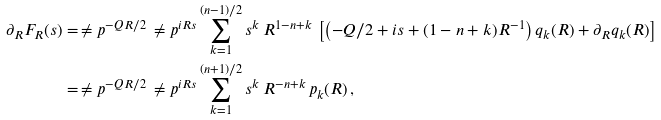<formula> <loc_0><loc_0><loc_500><loc_500>\partial _ { R } F _ { R } ( s ) & = \, \ne p ^ { - Q R / 2 } \, \ne p ^ { i R s } \sum _ { k = 1 } ^ { ( n - 1 ) / 2 } s ^ { k } \, R ^ { 1 - n + k } \, \left [ \left ( - Q / 2 + i s + ( 1 - n + k ) R ^ { - 1 } \right ) q _ { k } ( R ) + \partial _ { R } q _ { k } ( R ) \right ] \\ & = \, \ne p ^ { - Q R / 2 } \, \ne p ^ { i R s } \sum _ { k = 1 } ^ { ( n + 1 ) / 2 } s ^ { k } \, R ^ { - n + k } \, p _ { k } ( R ) \, ,</formula> 